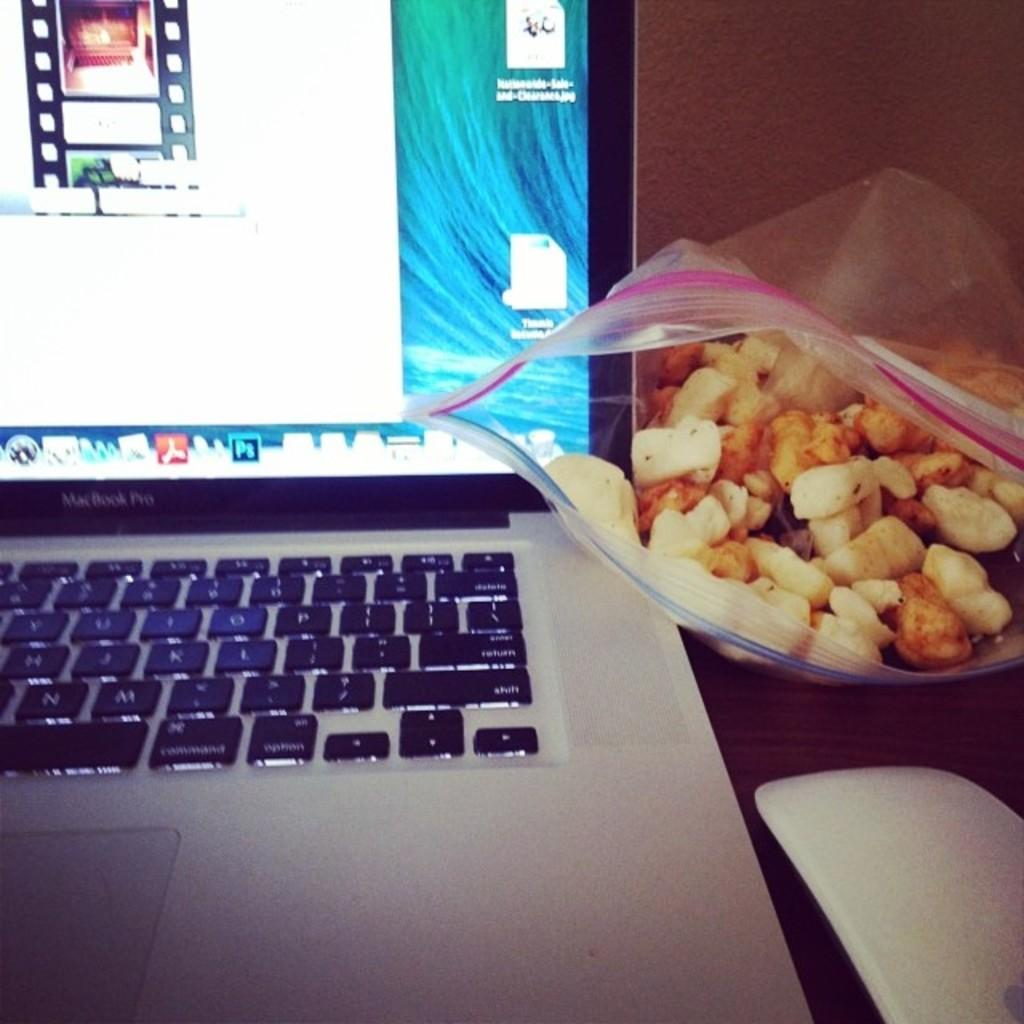What electronic device is visible in the image? There is a laptop in the image. What accessory is used with the laptop in the image? There is a computer mouse in the image. What type of food items can be seen in the image? There are food items in a packet in the image. What can be seen on the laptop screen? There are icons visible on the laptop screen. How does the baby interact with the laptop in the image? There is no baby present in the image, so it is not possible to answer that question. 